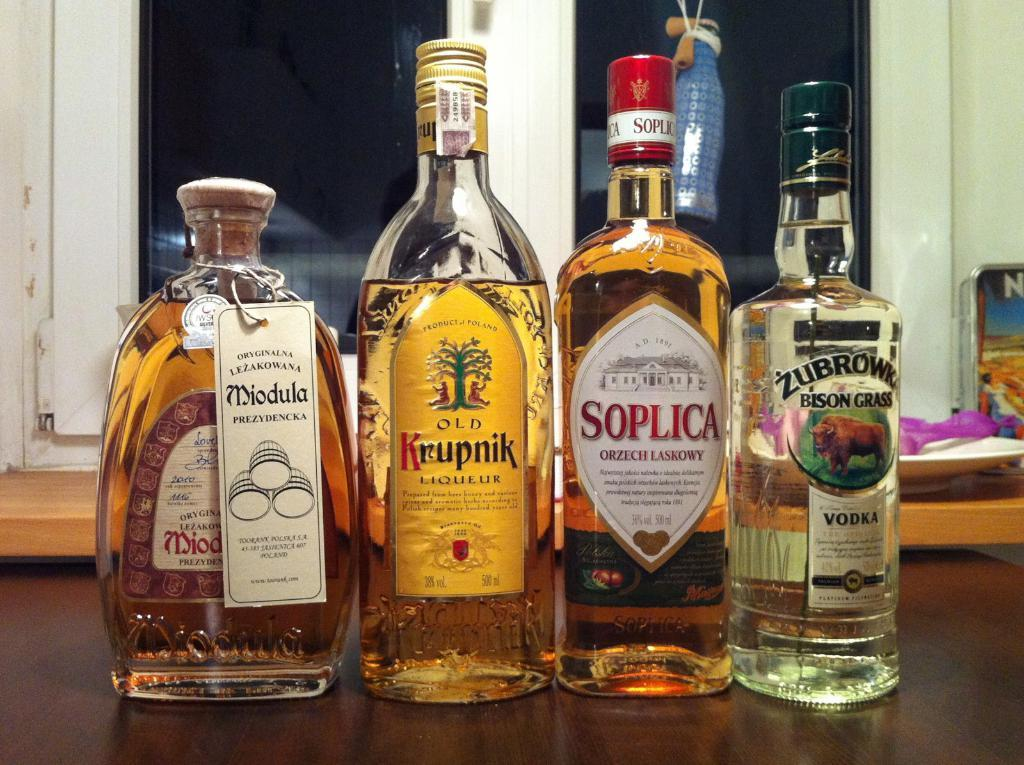Provide a one-sentence caption for the provided image. the word Soplica that is on a an alcohol bottle. 